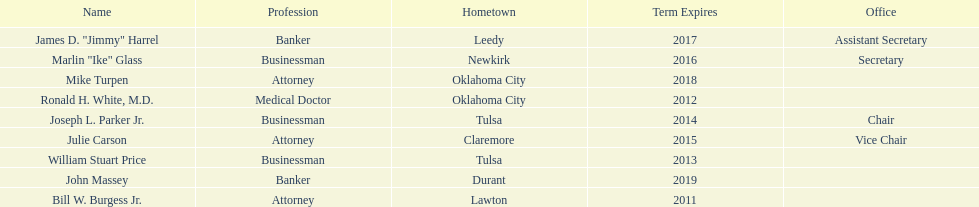How many members had businessman listed as their profession? 3. 